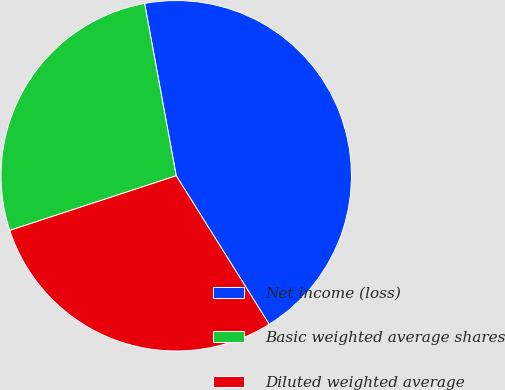Convert chart. <chart><loc_0><loc_0><loc_500><loc_500><pie_chart><fcel>Net income (loss)<fcel>Basic weighted average shares<fcel>Diluted weighted average<nl><fcel>43.99%<fcel>27.16%<fcel>28.85%<nl></chart> 